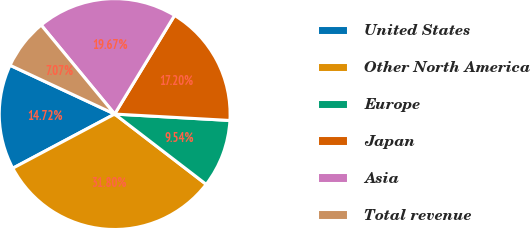<chart> <loc_0><loc_0><loc_500><loc_500><pie_chart><fcel>United States<fcel>Other North America<fcel>Europe<fcel>Japan<fcel>Asia<fcel>Total revenue<nl><fcel>14.72%<fcel>31.8%<fcel>9.54%<fcel>17.2%<fcel>19.67%<fcel>7.07%<nl></chart> 